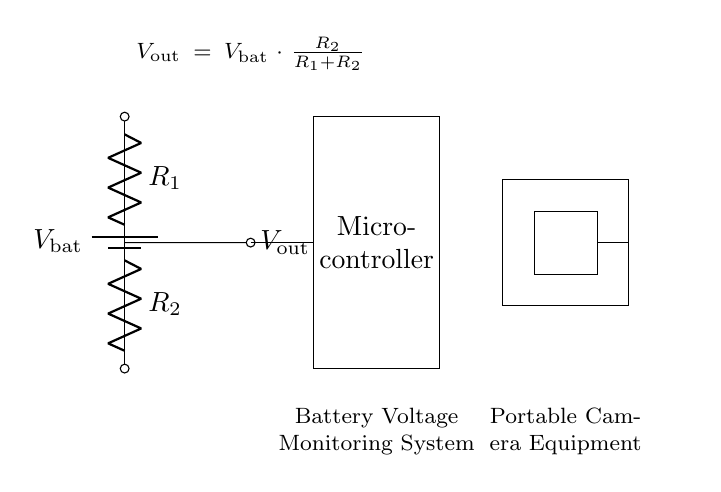What is the output voltage formula? The formula for the output voltage is given in the circuit diagram as Vout = Vbat * (R2 / (R1 + R2)). This indicates how the resistors R1 and R2 divide the input battery voltage (Vbat) to produce an output voltage (Vout).
Answer: Vout = Vbat * (R2 / (R1 + R2)) What does the microcontroller do? The microcontroller processes the output voltage from the voltage divider. It likely monitors the battery voltage to determine the remaining charge and manage power efficiency for the camera equipment.
Answer: Monitor battery voltage What are R1 and R2? R1 and R2 are resistors used in the voltage divider. They are crucial for determining how the input voltage from the battery is distributed to provide the desired output voltage.
Answer: Resistors Which component indicates the battery voltage? The component representing the battery voltage is labeled as Vbat in the circuit. It serves as the source of voltage that is being divided by the resistors R1 and R2.
Answer: Vbat What is the role of the voltage divider? The role of the voltage divider is to reduce the higher battery voltage Vbat to a lower output voltage Vout that can be safely read and processed by the microcontroller and the connected camera equipment.
Answer: Reduce voltage How does changing R1 affect Vout? If R1 is increased while R2 remains the same, the output voltage Vout will decrease according to the voltage divider formula. This is because a larger R1 leads to a smaller fraction of the total resistance, reducing the output voltage output relative to the battery voltage.
Answer: Decrease Vout 